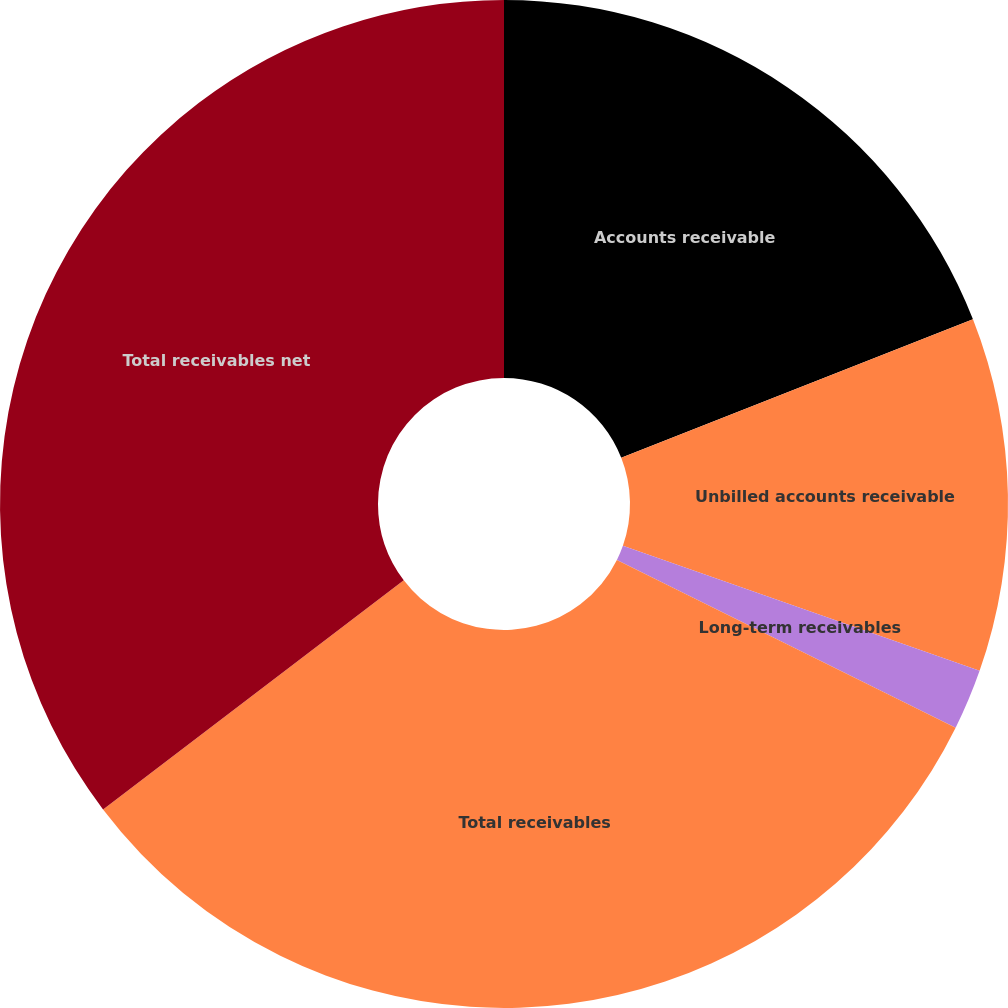Convert chart to OTSL. <chart><loc_0><loc_0><loc_500><loc_500><pie_chart><fcel>Accounts receivable<fcel>Unbilled accounts receivable<fcel>Long-term receivables<fcel>Total receivables<fcel>Total receivables net<nl><fcel>19.03%<fcel>11.34%<fcel>1.95%<fcel>32.32%<fcel>35.36%<nl></chart> 